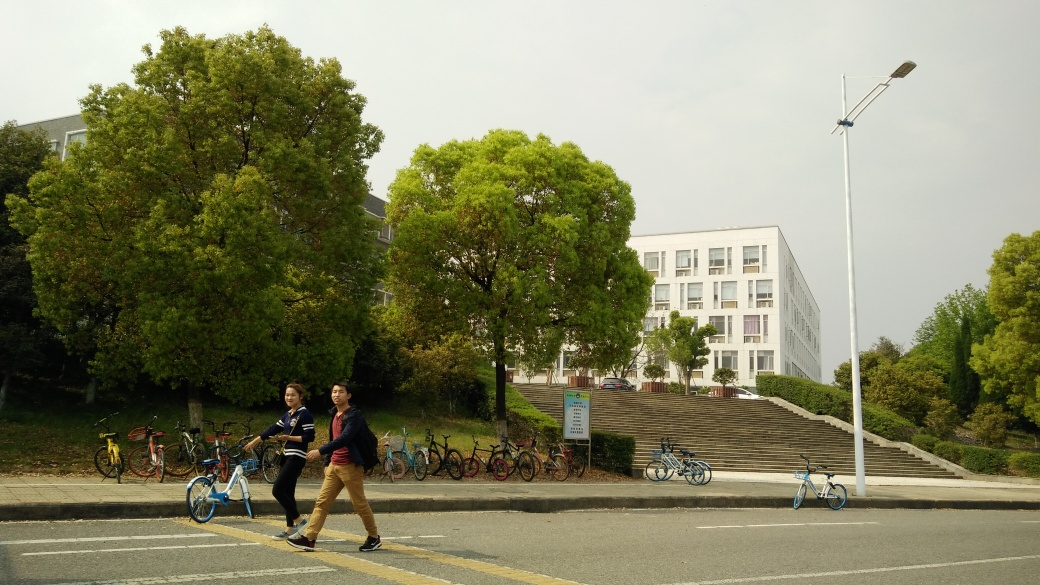Does the image have any motion blur?
 No 